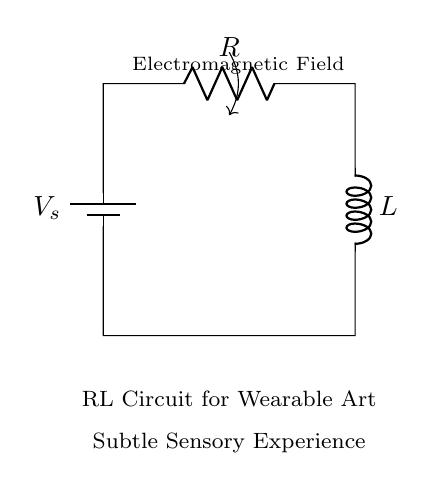What is the voltage source in this circuit? The voltage source is represented as \( V_s \) in the diagram, indicating the required potential difference provided to the circuit components.
Answer: V_s What types of components are shown in the circuit? The circuit contains a resistor \( R \) and an inductor \( L \), both marked in the diagram, indicating their presence for creating an RL circuit.
Answer: Resistor and Inductor What does the electromagnetic field arrow indicate? The arrow labeled "Electromagnetic Field" shows that the circuit generates electromagnetic fields, a crucial feature for enabling sensory experiences in wearable art.
Answer: Electromagnetic Field What is the configuration of the components in this circuit? The configuration indicates a series connection where the battery, resistor, and inductor are aligned sequentially, with the current flowing from the battery through the resistor and into the inductor.
Answer: Series How does the resistor affect the current in the circuit? The resistor \( R \) limits the amount of current flowing through the circuit according to Ohm's Law, reducing the overall current based on its resistance value and the voltage supplied by the source.
Answer: Limits current Why is an inductor used in this wearable art circuit? The inductor \( L \) is used to store energy in a magnetic field, which, when coupled with the resistor, creates a unique response to changes in current, ideal for generating subtle electromagnetic effects in wearable applications.
Answer: Energy storage 